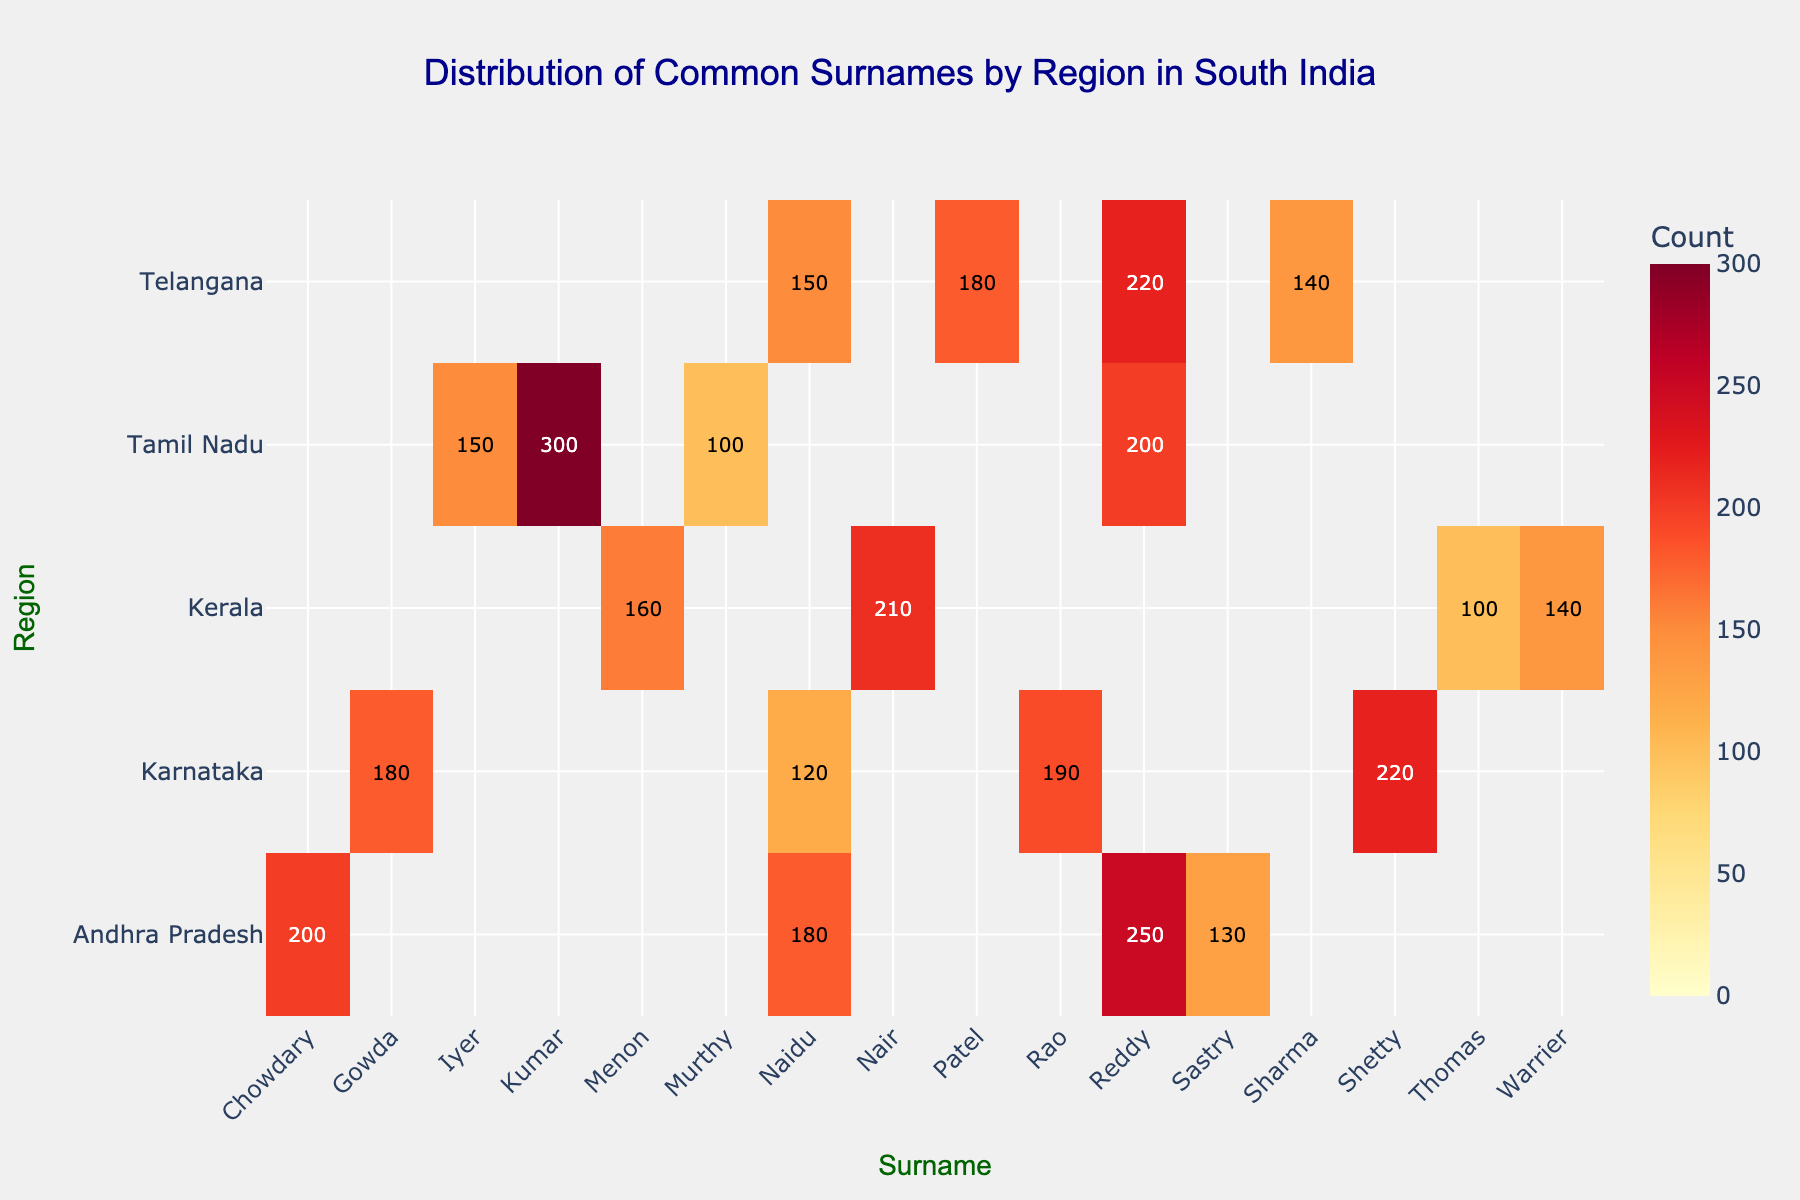What's the title of the heatmap? The title of the heatmap is usually placed at the top center of the figure. It provides a description of the content depicted in the figure.
Answer: Distribution of Common Surnames by Region in South India What's the highest count for the surname 'Reddy' and in which region does it appear? Look for the highest value in the column corresponding to the surname 'Reddy'. The values should be compared across different regions. In this case, the highest count is in Andhra Pradesh.
Answer: 250 in Andhra Pradesh Which region has the most diverse range of surnames with counts above 100? Examine each row representing a region and count how many different surnames have values greater than 100. The region with the highest number of these surnames is Karnataka.
Answer: Karnataka What are the two regions with the highest counts for the surname 'Naidu', and what are the counts? Identify the values in the 'Naidu' column and find the two highest numbers. The regions corresponding to these values are Andhra Pradesh and Telangana.
Answer: Andhra Pradesh (180) and Telangana (150) Which surname in Tamil Nadu has the highest count, and what is that count? In the row for Tamil Nadu, identify the highest value across the surnames. The surname with this value is 'Kumar'.
Answer: Kumar with 300 What's the total count of the surname 'Naidu' across all regions? Add the counts of the 'Naidu' surname across all rows (regions): Tamil Nadu, Karnataka, Andhra Pradesh, and Telangana.
Answer: 570 Is there any surname that appears in all regions? Which ones are they? By scanning each column, identify any surnames that have counts in all rows (regions). The surnames 'Reddy' and 'Naidu' appear in all regions.
Answer: Reddy and Naidu Which region has less than 150 counts for all the listed surnames? Verify each row to see if all its values are under 150. Kerala has counts for all surnames below 150.
Answer: Kerala What's the sum of counts for the surname 'Reddy' in Tamil Nadu and Telangana? Add the counts of the surname 'Reddy' for Tamil Nadu and Telangana.
Answer: 200 + 220 = 420 Which region has the lowest count for the surname 'Murthy', and what is that count? Look at the values under the surname 'Murthy' and identify the region with the lowest count which should only appear for Tamil Nadu.
Answer: Tamil Nadu with 100 